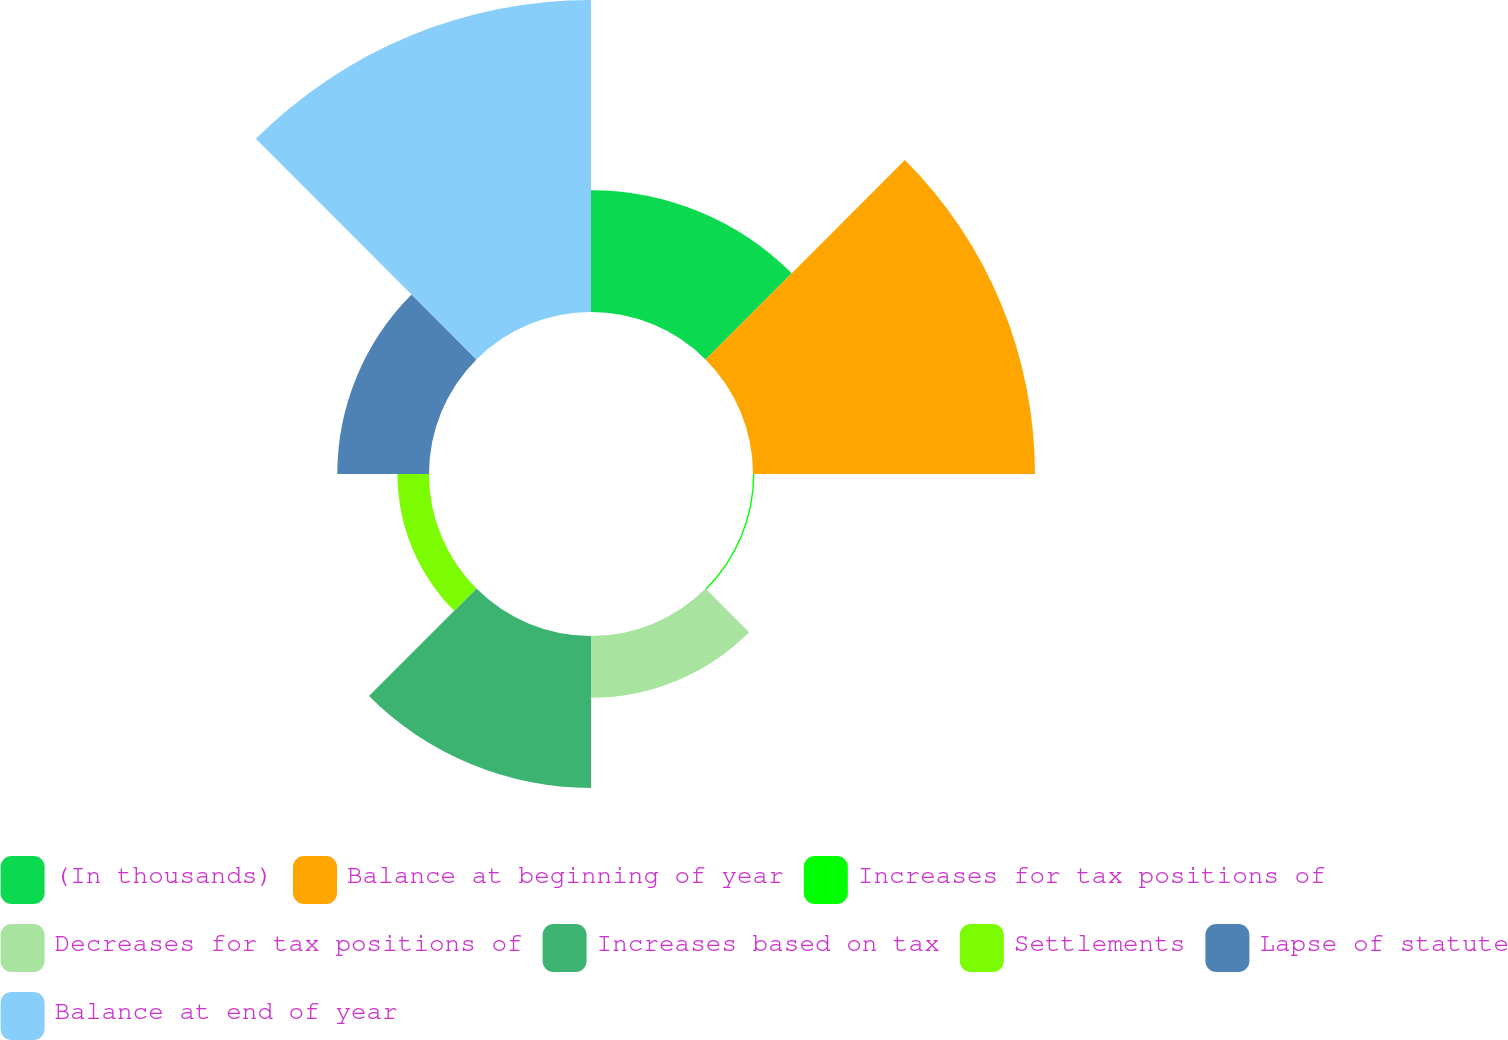Convert chart. <chart><loc_0><loc_0><loc_500><loc_500><pie_chart><fcel>(In thousands)<fcel>Balance at beginning of year<fcel>Increases for tax positions of<fcel>Decreases for tax positions of<fcel>Increases based on tax<fcel>Settlements<fcel>Lapse of statute<fcel>Balance at end of year<nl><fcel>11.56%<fcel>26.75%<fcel>0.13%<fcel>5.85%<fcel>14.42%<fcel>2.99%<fcel>8.7%<fcel>29.6%<nl></chart> 